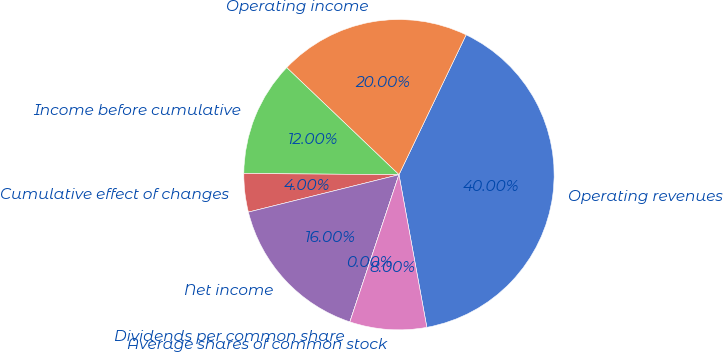Convert chart. <chart><loc_0><loc_0><loc_500><loc_500><pie_chart><fcel>Operating revenues<fcel>Operating income<fcel>Income before cumulative<fcel>Cumulative effect of changes<fcel>Net income<fcel>Dividends per common share<fcel>Average shares of common stock<nl><fcel>40.0%<fcel>20.0%<fcel>12.0%<fcel>4.0%<fcel>16.0%<fcel>0.0%<fcel>8.0%<nl></chart> 